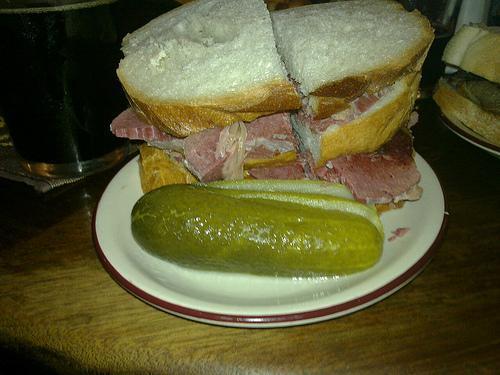How many plates are there?
Give a very brief answer. 2. 